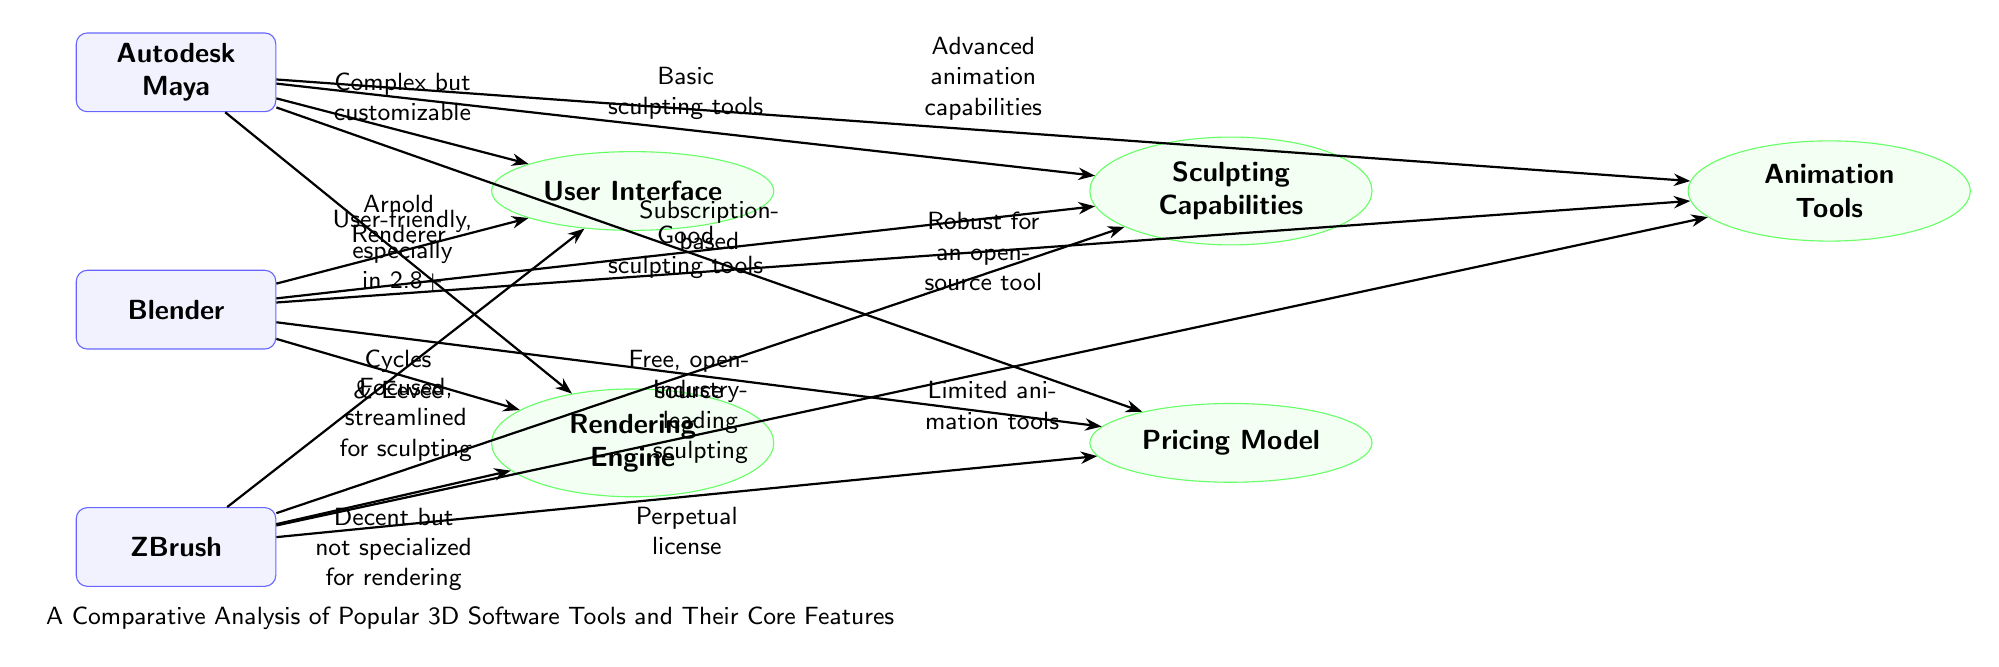What are the three 3D software tools represented in the diagram? The diagram features three software tools: Autodesk Maya, Blender, and ZBrush. These are presented as nodes in the upper section of the diagram.
Answer: Autodesk Maya, Blender, ZBrush Which software has the most advanced animation capabilities? From the arrows pointing towards the Animation Tools feature, Autodesk Maya is indicated as having advanced animation capabilities, as reflected in the label connected to it.
Answer: Autodesk Maya What is Blender's model in terms of pricing? The diagram clearly shows that Blender is labeled as free and open-source, which is stated in the Pricing Model feature.
Answer: Free, open-source How does ZBrush rate in terms of sculpting capabilities compared to the other tools? The diagram designates ZBrush as having industry-leading sculpting capabilities when compared to Maya's basic tools and Blender's good sculpting tools. This is conveyed through the points connecting these software tools to the Sculpting Capabilities feature.
Answer: Industry-leading What is the rendering engine used by Autodesk Maya? The diagram specifically indicates that Autodesk Maya utilizes the Arnold Renderer for its rendering capabilities, connecting this directly from the Maya node to the Rendering Engine feature.
Answer: Arnold Renderer Which software is user-friendly especially in version 2.8 and later? The arrow leading from the Blender node to the User Interface feature mentions it as user-friendly, particularly highlighting version 2.8 and later as a significant improvement in usability.
Answer: User-friendly, especially in 2.8+ What are the unique features of ZBrush in terms of the User Interface? According to the diagram, the User Interface for ZBrush is described as focused and streamlined for sculpting, emphasizing its specialization in that area compared to the other tools.
Answer: Focused, streamlined for sculpting Which of the three software tools has limitations in animation tools? The diagram details that ZBrush has limited animation tools compared to Autodesk Maya and Blender, which both offer stronger capabilities in this feature.
Answer: Limited animation tools What type of licensing model is used for ZBrush? The Pricing Model feature shows that ZBrush operates on a perpetual license, distinguishing it from Blender’s free model and Maya's subscription-based model.
Answer: Perpetual license 